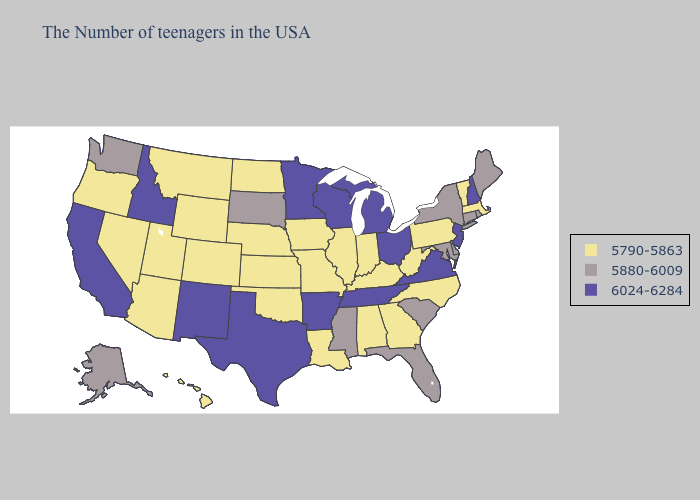What is the value of Illinois?
Answer briefly. 5790-5863. Does Arkansas have the highest value in the USA?
Short answer required. Yes. What is the lowest value in the Northeast?
Concise answer only. 5790-5863. Does Florida have a higher value than California?
Short answer required. No. Does Tennessee have the same value as California?
Answer briefly. Yes. What is the highest value in states that border Oregon?
Be succinct. 6024-6284. Does Maine have the lowest value in the USA?
Write a very short answer. No. Among the states that border North Carolina , which have the lowest value?
Answer briefly. Georgia. What is the highest value in the South ?
Give a very brief answer. 6024-6284. What is the highest value in states that border Massachusetts?
Keep it brief. 6024-6284. Name the states that have a value in the range 6024-6284?
Give a very brief answer. New Hampshire, New Jersey, Virginia, Ohio, Michigan, Tennessee, Wisconsin, Arkansas, Minnesota, Texas, New Mexico, Idaho, California. What is the value of Massachusetts?
Write a very short answer. 5790-5863. What is the value of Kentucky?
Be succinct. 5790-5863. How many symbols are there in the legend?
Answer briefly. 3. What is the value of Hawaii?
Keep it brief. 5790-5863. 